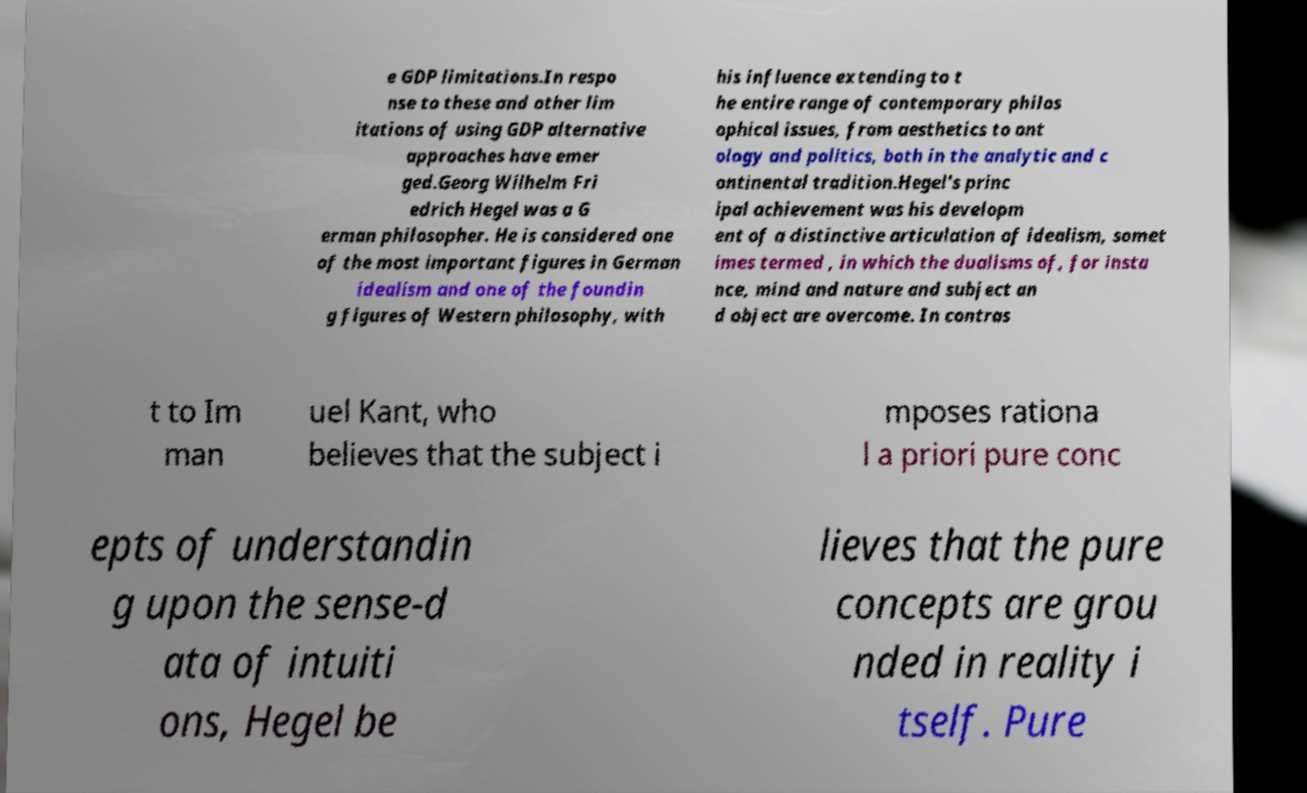Please read and relay the text visible in this image. What does it say? e GDP limitations.In respo nse to these and other lim itations of using GDP alternative approaches have emer ged.Georg Wilhelm Fri edrich Hegel was a G erman philosopher. He is considered one of the most important figures in German idealism and one of the foundin g figures of Western philosophy, with his influence extending to t he entire range of contemporary philos ophical issues, from aesthetics to ont ology and politics, both in the analytic and c ontinental tradition.Hegel's princ ipal achievement was his developm ent of a distinctive articulation of idealism, somet imes termed , in which the dualisms of, for insta nce, mind and nature and subject an d object are overcome. In contras t to Im man uel Kant, who believes that the subject i mposes rationa l a priori pure conc epts of understandin g upon the sense-d ata of intuiti ons, Hegel be lieves that the pure concepts are grou nded in reality i tself. Pure 